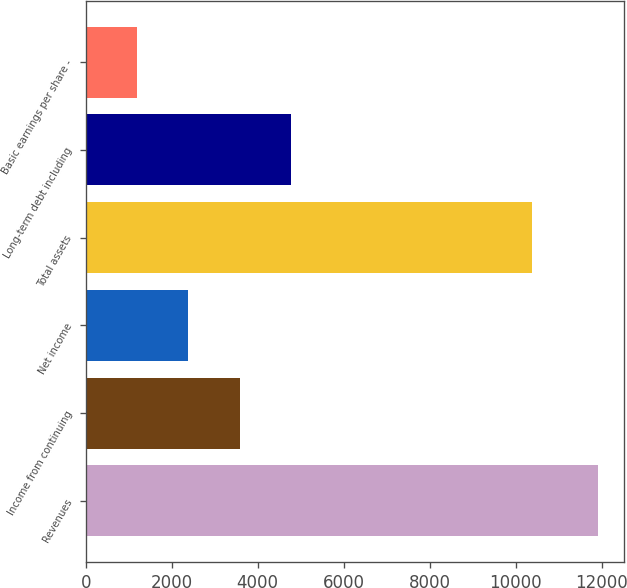Convert chart to OTSL. <chart><loc_0><loc_0><loc_500><loc_500><bar_chart><fcel>Revenues<fcel>Income from continuing<fcel>Net income<fcel>Total assets<fcel>Long-term debt including<fcel>Basic earnings per share -<nl><fcel>11920.3<fcel>3578.02<fcel>2386.26<fcel>10391.1<fcel>4769.78<fcel>1194.5<nl></chart> 